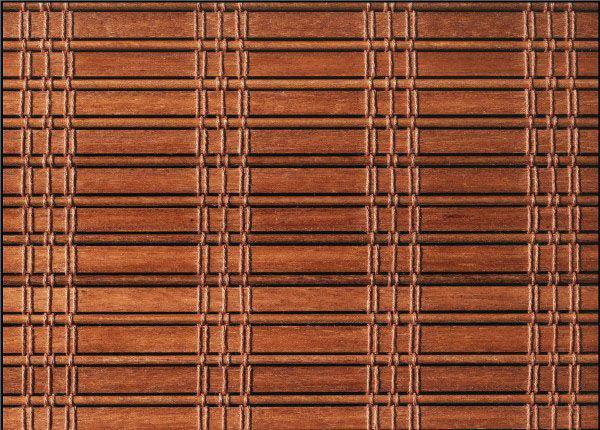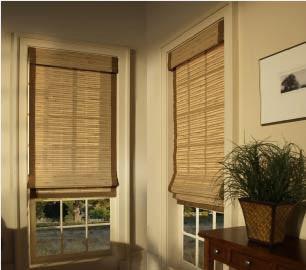The first image is the image on the left, the second image is the image on the right. Considering the images on both sides, is "There are three blinds." valid? Answer yes or no. Yes. The first image is the image on the left, the second image is the image on the right. For the images shown, is this caption "In the image to the left, some chairs are visible in front of the window." true? Answer yes or no. No. 